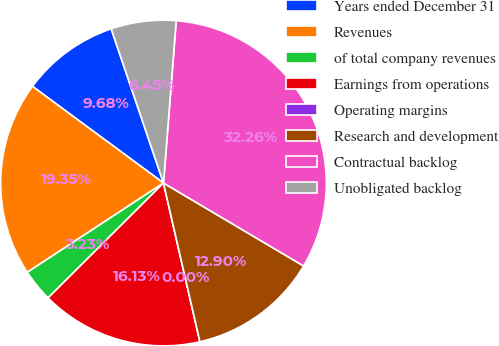<chart> <loc_0><loc_0><loc_500><loc_500><pie_chart><fcel>Years ended December 31<fcel>Revenues<fcel>of total company revenues<fcel>Earnings from operations<fcel>Operating margins<fcel>Research and development<fcel>Contractual backlog<fcel>Unobligated backlog<nl><fcel>9.68%<fcel>19.35%<fcel>3.23%<fcel>16.13%<fcel>0.0%<fcel>12.9%<fcel>32.26%<fcel>6.45%<nl></chart> 